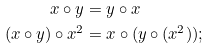Convert formula to latex. <formula><loc_0><loc_0><loc_500><loc_500>x \circ y & = y \circ x \\ ( x \circ y ) \circ x ^ { 2 } & = x \circ ( y \circ ( x ^ { 2 } ) ) ;</formula> 